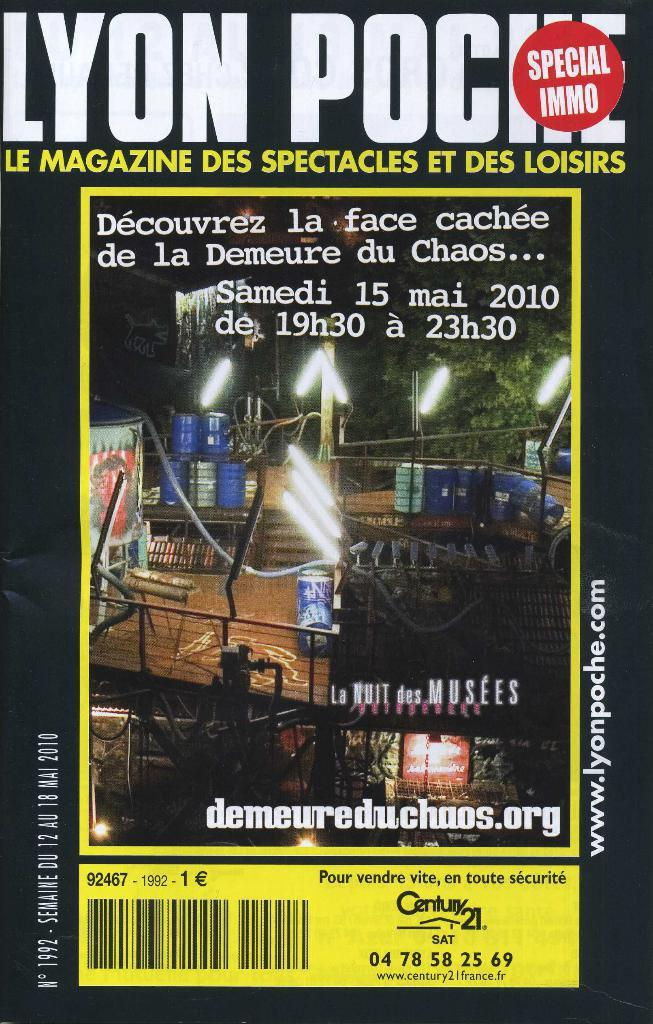<image>
Relay a brief, clear account of the picture shown. A magazine cover has a Century 21 ad on the bottom. 